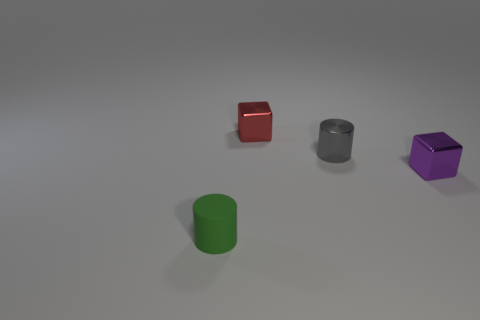Add 4 tiny red things. How many objects exist? 8 Subtract 0 green spheres. How many objects are left? 4 Subtract all yellow blocks. Subtract all red spheres. How many blocks are left? 2 Subtract all purple metallic blocks. Subtract all red metal objects. How many objects are left? 2 Add 4 tiny green objects. How many tiny green objects are left? 5 Add 4 small red shiny things. How many small red shiny things exist? 5 